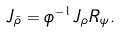Convert formula to latex. <formula><loc_0><loc_0><loc_500><loc_500>J _ { \tilde { \rho } } = \phi ^ { - 1 } J _ { \rho } R _ { \psi } .</formula> 